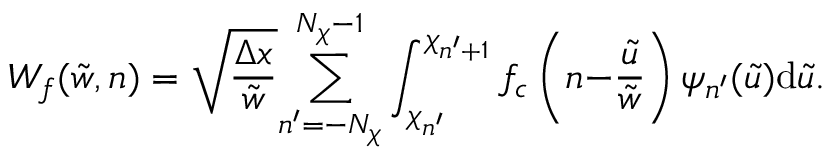<formula> <loc_0><loc_0><loc_500><loc_500>W _ { f } ( \tilde { w } , n ) = \sqrt { \frac { \Delta x } { \tilde { w } } } { \sum _ { n ^ { \prime } = - N _ { \chi } } ^ { N _ { \chi } - 1 } } \int _ { \chi _ { n ^ { \prime } } } ^ { \chi _ { n ^ { \prime } { + } 1 } } f _ { c } \left ( n { - } \frac { \tilde { u } } { \tilde { w } } \right ) \psi _ { n ^ { \prime } } ( \tilde { u } ) d \tilde { u } .</formula> 